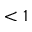Convert formula to latex. <formula><loc_0><loc_0><loc_500><loc_500>< 1</formula> 